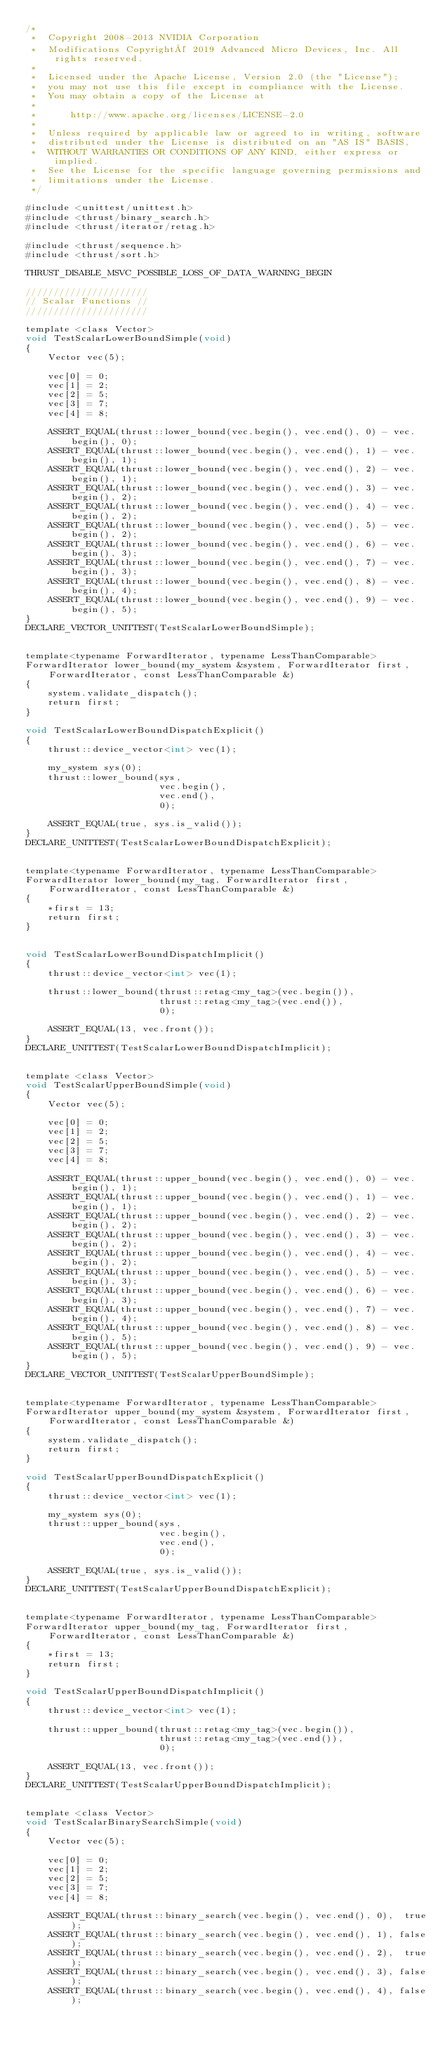Convert code to text. <code><loc_0><loc_0><loc_500><loc_500><_Cuda_>/*
 *  Copyright 2008-2013 NVIDIA Corporation
 *  Modifications Copyright© 2019 Advanced Micro Devices, Inc. All rights reserved.
 *
 *  Licensed under the Apache License, Version 2.0 (the "License");
 *  you may not use this file except in compliance with the License.
 *  You may obtain a copy of the License at
 *
 *      http://www.apache.org/licenses/LICENSE-2.0
 *
 *  Unless required by applicable law or agreed to in writing, software
 *  distributed under the License is distributed on an "AS IS" BASIS,
 *  WITHOUT WARRANTIES OR CONDITIONS OF ANY KIND, either express or implied.
 *  See the License for the specific language governing permissions and
 *  limitations under the License.
 */
 
#include <unittest/unittest.h>
#include <thrust/binary_search.h>
#include <thrust/iterator/retag.h>

#include <thrust/sequence.h>
#include <thrust/sort.h>

THRUST_DISABLE_MSVC_POSSIBLE_LOSS_OF_DATA_WARNING_BEGIN

//////////////////////
// Scalar Functions //
//////////////////////

template <class Vector>
void TestScalarLowerBoundSimple(void)
{
    Vector vec(5);

    vec[0] = 0;
    vec[1] = 2;
    vec[2] = 5;
    vec[3] = 7;
    vec[4] = 8;

    ASSERT_EQUAL(thrust::lower_bound(vec.begin(), vec.end(), 0) - vec.begin(), 0);
    ASSERT_EQUAL(thrust::lower_bound(vec.begin(), vec.end(), 1) - vec.begin(), 1);
    ASSERT_EQUAL(thrust::lower_bound(vec.begin(), vec.end(), 2) - vec.begin(), 1);
    ASSERT_EQUAL(thrust::lower_bound(vec.begin(), vec.end(), 3) - vec.begin(), 2);
    ASSERT_EQUAL(thrust::lower_bound(vec.begin(), vec.end(), 4) - vec.begin(), 2);
    ASSERT_EQUAL(thrust::lower_bound(vec.begin(), vec.end(), 5) - vec.begin(), 2);
    ASSERT_EQUAL(thrust::lower_bound(vec.begin(), vec.end(), 6) - vec.begin(), 3);
    ASSERT_EQUAL(thrust::lower_bound(vec.begin(), vec.end(), 7) - vec.begin(), 3);
    ASSERT_EQUAL(thrust::lower_bound(vec.begin(), vec.end(), 8) - vec.begin(), 4);
    ASSERT_EQUAL(thrust::lower_bound(vec.begin(), vec.end(), 9) - vec.begin(), 5);
}
DECLARE_VECTOR_UNITTEST(TestScalarLowerBoundSimple);


template<typename ForwardIterator, typename LessThanComparable>
ForwardIterator lower_bound(my_system &system, ForwardIterator first, ForwardIterator, const LessThanComparable &)
{
    system.validate_dispatch();
    return first;
}

void TestScalarLowerBoundDispatchExplicit()
{
    thrust::device_vector<int> vec(1);

    my_system sys(0);
    thrust::lower_bound(sys,
                        vec.begin(),
                        vec.end(),
                        0);

    ASSERT_EQUAL(true, sys.is_valid());
}
DECLARE_UNITTEST(TestScalarLowerBoundDispatchExplicit);


template<typename ForwardIterator, typename LessThanComparable>
ForwardIterator lower_bound(my_tag, ForwardIterator first, ForwardIterator, const LessThanComparable &)
{
    *first = 13;
    return first;
}


void TestScalarLowerBoundDispatchImplicit()
{
    thrust::device_vector<int> vec(1);

    thrust::lower_bound(thrust::retag<my_tag>(vec.begin()),
                        thrust::retag<my_tag>(vec.end()),
                        0);

    ASSERT_EQUAL(13, vec.front());
}
DECLARE_UNITTEST(TestScalarLowerBoundDispatchImplicit);


template <class Vector>
void TestScalarUpperBoundSimple(void)
{
    Vector vec(5);

    vec[0] = 0;
    vec[1] = 2;
    vec[2] = 5;
    vec[3] = 7;
    vec[4] = 8;

    ASSERT_EQUAL(thrust::upper_bound(vec.begin(), vec.end(), 0) - vec.begin(), 1);
    ASSERT_EQUAL(thrust::upper_bound(vec.begin(), vec.end(), 1) - vec.begin(), 1);
    ASSERT_EQUAL(thrust::upper_bound(vec.begin(), vec.end(), 2) - vec.begin(), 2);
    ASSERT_EQUAL(thrust::upper_bound(vec.begin(), vec.end(), 3) - vec.begin(), 2);
    ASSERT_EQUAL(thrust::upper_bound(vec.begin(), vec.end(), 4) - vec.begin(), 2);
    ASSERT_EQUAL(thrust::upper_bound(vec.begin(), vec.end(), 5) - vec.begin(), 3);
    ASSERT_EQUAL(thrust::upper_bound(vec.begin(), vec.end(), 6) - vec.begin(), 3);
    ASSERT_EQUAL(thrust::upper_bound(vec.begin(), vec.end(), 7) - vec.begin(), 4);
    ASSERT_EQUAL(thrust::upper_bound(vec.begin(), vec.end(), 8) - vec.begin(), 5);
    ASSERT_EQUAL(thrust::upper_bound(vec.begin(), vec.end(), 9) - vec.begin(), 5);
}
DECLARE_VECTOR_UNITTEST(TestScalarUpperBoundSimple);


template<typename ForwardIterator, typename LessThanComparable>
ForwardIterator upper_bound(my_system &system, ForwardIterator first, ForwardIterator, const LessThanComparable &)
{
    system.validate_dispatch();
    return first;
}

void TestScalarUpperBoundDispatchExplicit()
{
    thrust::device_vector<int> vec(1);

    my_system sys(0);
    thrust::upper_bound(sys,
                        vec.begin(),
                        vec.end(),
                        0);

    ASSERT_EQUAL(true, sys.is_valid());
}
DECLARE_UNITTEST(TestScalarUpperBoundDispatchExplicit);


template<typename ForwardIterator, typename LessThanComparable>
ForwardIterator upper_bound(my_tag, ForwardIterator first, ForwardIterator, const LessThanComparable &)
{
    *first = 13;
    return first;
}

void TestScalarUpperBoundDispatchImplicit()
{
    thrust::device_vector<int> vec(1);

    thrust::upper_bound(thrust::retag<my_tag>(vec.begin()),
                        thrust::retag<my_tag>(vec.end()),
                        0);

    ASSERT_EQUAL(13, vec.front());
}
DECLARE_UNITTEST(TestScalarUpperBoundDispatchImplicit);


template <class Vector>
void TestScalarBinarySearchSimple(void)
{
    Vector vec(5);

    vec[0] = 0;
    vec[1] = 2;
    vec[2] = 5;
    vec[3] = 7;
    vec[4] = 8;

    ASSERT_EQUAL(thrust::binary_search(vec.begin(), vec.end(), 0),  true);
    ASSERT_EQUAL(thrust::binary_search(vec.begin(), vec.end(), 1), false);
    ASSERT_EQUAL(thrust::binary_search(vec.begin(), vec.end(), 2),  true);
    ASSERT_EQUAL(thrust::binary_search(vec.begin(), vec.end(), 3), false);
    ASSERT_EQUAL(thrust::binary_search(vec.begin(), vec.end(), 4), false);</code> 